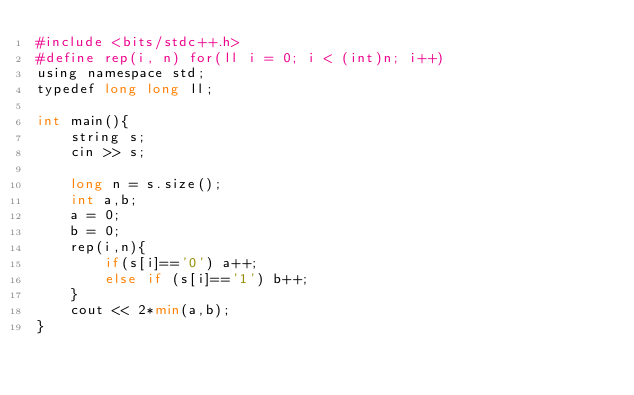<code> <loc_0><loc_0><loc_500><loc_500><_Python_>#include <bits/stdc++.h>
#define rep(i, n) for(ll i = 0; i < (int)n; i++)
using namespace std;
typedef long long ll;

int main(){
    string s;
    cin >> s;
    
    long n = s.size();
    int a,b;
    a = 0;
    b = 0;
    rep(i,n){
        if(s[i]=='0') a++;
        else if (s[i]=='1') b++;
    }
    cout << 2*min(a,b);
}

</code> 